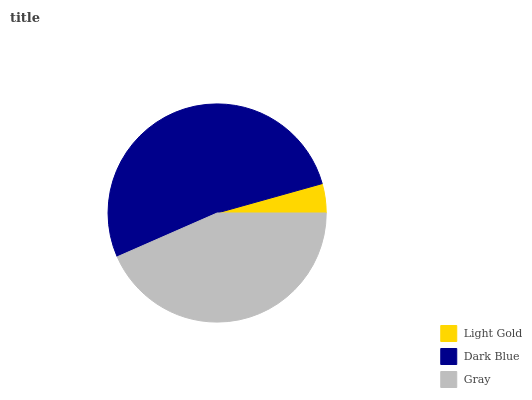Is Light Gold the minimum?
Answer yes or no. Yes. Is Dark Blue the maximum?
Answer yes or no. Yes. Is Gray the minimum?
Answer yes or no. No. Is Gray the maximum?
Answer yes or no. No. Is Dark Blue greater than Gray?
Answer yes or no. Yes. Is Gray less than Dark Blue?
Answer yes or no. Yes. Is Gray greater than Dark Blue?
Answer yes or no. No. Is Dark Blue less than Gray?
Answer yes or no. No. Is Gray the high median?
Answer yes or no. Yes. Is Gray the low median?
Answer yes or no. Yes. Is Dark Blue the high median?
Answer yes or no. No. Is Light Gold the low median?
Answer yes or no. No. 